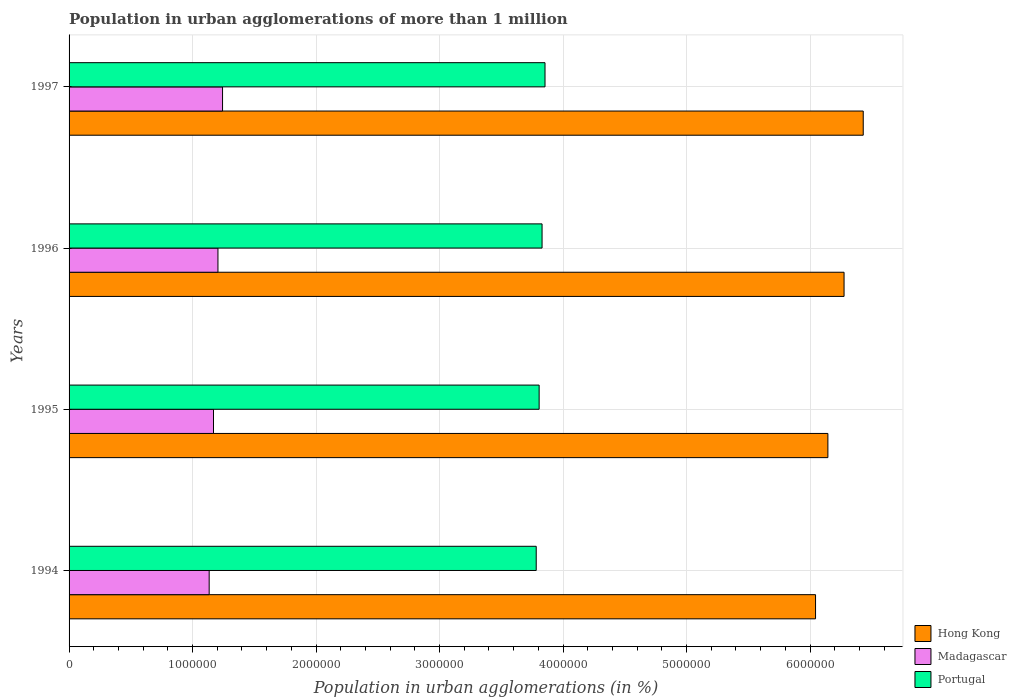Are the number of bars per tick equal to the number of legend labels?
Offer a very short reply. Yes. How many bars are there on the 1st tick from the top?
Give a very brief answer. 3. What is the population in urban agglomerations in Madagascar in 1994?
Your answer should be very brief. 1.13e+06. Across all years, what is the maximum population in urban agglomerations in Madagascar?
Your answer should be very brief. 1.24e+06. Across all years, what is the minimum population in urban agglomerations in Madagascar?
Your response must be concise. 1.13e+06. In which year was the population in urban agglomerations in Hong Kong maximum?
Ensure brevity in your answer.  1997. What is the total population in urban agglomerations in Hong Kong in the graph?
Your response must be concise. 2.49e+07. What is the difference between the population in urban agglomerations in Portugal in 1996 and that in 1997?
Your answer should be very brief. -2.38e+04. What is the difference between the population in urban agglomerations in Portugal in 1994 and the population in urban agglomerations in Madagascar in 1996?
Provide a short and direct response. 2.58e+06. What is the average population in urban agglomerations in Portugal per year?
Keep it short and to the point. 3.82e+06. In the year 1997, what is the difference between the population in urban agglomerations in Hong Kong and population in urban agglomerations in Madagascar?
Your response must be concise. 5.19e+06. In how many years, is the population in urban agglomerations in Hong Kong greater than 3200000 %?
Offer a terse response. 4. What is the ratio of the population in urban agglomerations in Madagascar in 1994 to that in 1995?
Make the answer very short. 0.97. Is the population in urban agglomerations in Portugal in 1995 less than that in 1996?
Give a very brief answer. Yes. Is the difference between the population in urban agglomerations in Hong Kong in 1994 and 1996 greater than the difference between the population in urban agglomerations in Madagascar in 1994 and 1996?
Your answer should be very brief. No. What is the difference between the highest and the second highest population in urban agglomerations in Hong Kong?
Give a very brief answer. 1.55e+05. What is the difference between the highest and the lowest population in urban agglomerations in Hong Kong?
Ensure brevity in your answer.  3.86e+05. What does the 2nd bar from the top in 1995 represents?
Provide a succinct answer. Madagascar. Is it the case that in every year, the sum of the population in urban agglomerations in Madagascar and population in urban agglomerations in Portugal is greater than the population in urban agglomerations in Hong Kong?
Ensure brevity in your answer.  No. How many years are there in the graph?
Make the answer very short. 4. What is the difference between two consecutive major ticks on the X-axis?
Offer a very short reply. 1.00e+06. Are the values on the major ticks of X-axis written in scientific E-notation?
Give a very brief answer. No. What is the title of the graph?
Your answer should be compact. Population in urban agglomerations of more than 1 million. Does "Hong Kong" appear as one of the legend labels in the graph?
Make the answer very short. Yes. What is the label or title of the X-axis?
Provide a succinct answer. Population in urban agglomerations (in %). What is the label or title of the Y-axis?
Offer a very short reply. Years. What is the Population in urban agglomerations (in %) of Hong Kong in 1994?
Your response must be concise. 6.04e+06. What is the Population in urban agglomerations (in %) in Madagascar in 1994?
Keep it short and to the point. 1.13e+06. What is the Population in urban agglomerations (in %) in Portugal in 1994?
Offer a terse response. 3.78e+06. What is the Population in urban agglomerations (in %) of Hong Kong in 1995?
Make the answer very short. 6.14e+06. What is the Population in urban agglomerations (in %) of Madagascar in 1995?
Your response must be concise. 1.17e+06. What is the Population in urban agglomerations (in %) of Portugal in 1995?
Your answer should be compact. 3.81e+06. What is the Population in urban agglomerations (in %) in Hong Kong in 1996?
Ensure brevity in your answer.  6.28e+06. What is the Population in urban agglomerations (in %) in Madagascar in 1996?
Your response must be concise. 1.21e+06. What is the Population in urban agglomerations (in %) of Portugal in 1996?
Give a very brief answer. 3.83e+06. What is the Population in urban agglomerations (in %) of Hong Kong in 1997?
Ensure brevity in your answer.  6.43e+06. What is the Population in urban agglomerations (in %) of Madagascar in 1997?
Make the answer very short. 1.24e+06. What is the Population in urban agglomerations (in %) in Portugal in 1997?
Give a very brief answer. 3.85e+06. Across all years, what is the maximum Population in urban agglomerations (in %) of Hong Kong?
Offer a terse response. 6.43e+06. Across all years, what is the maximum Population in urban agglomerations (in %) of Madagascar?
Offer a very short reply. 1.24e+06. Across all years, what is the maximum Population in urban agglomerations (in %) of Portugal?
Your answer should be compact. 3.85e+06. Across all years, what is the minimum Population in urban agglomerations (in %) in Hong Kong?
Offer a very short reply. 6.04e+06. Across all years, what is the minimum Population in urban agglomerations (in %) in Madagascar?
Provide a succinct answer. 1.13e+06. Across all years, what is the minimum Population in urban agglomerations (in %) in Portugal?
Give a very brief answer. 3.78e+06. What is the total Population in urban agglomerations (in %) of Hong Kong in the graph?
Ensure brevity in your answer.  2.49e+07. What is the total Population in urban agglomerations (in %) of Madagascar in the graph?
Provide a succinct answer. 4.75e+06. What is the total Population in urban agglomerations (in %) in Portugal in the graph?
Offer a very short reply. 1.53e+07. What is the difference between the Population in urban agglomerations (in %) in Hong Kong in 1994 and that in 1995?
Offer a terse response. -1.00e+05. What is the difference between the Population in urban agglomerations (in %) in Madagascar in 1994 and that in 1995?
Provide a short and direct response. -3.50e+04. What is the difference between the Population in urban agglomerations (in %) in Portugal in 1994 and that in 1995?
Give a very brief answer. -2.36e+04. What is the difference between the Population in urban agglomerations (in %) in Hong Kong in 1994 and that in 1996?
Your answer should be compact. -2.31e+05. What is the difference between the Population in urban agglomerations (in %) in Madagascar in 1994 and that in 1996?
Your answer should be compact. -7.12e+04. What is the difference between the Population in urban agglomerations (in %) of Portugal in 1994 and that in 1996?
Make the answer very short. -4.73e+04. What is the difference between the Population in urban agglomerations (in %) of Hong Kong in 1994 and that in 1997?
Keep it short and to the point. -3.86e+05. What is the difference between the Population in urban agglomerations (in %) of Madagascar in 1994 and that in 1997?
Your answer should be compact. -1.08e+05. What is the difference between the Population in urban agglomerations (in %) of Portugal in 1994 and that in 1997?
Make the answer very short. -7.11e+04. What is the difference between the Population in urban agglomerations (in %) in Hong Kong in 1995 and that in 1996?
Make the answer very short. -1.31e+05. What is the difference between the Population in urban agglomerations (in %) in Madagascar in 1995 and that in 1996?
Give a very brief answer. -3.61e+04. What is the difference between the Population in urban agglomerations (in %) of Portugal in 1995 and that in 1996?
Offer a very short reply. -2.37e+04. What is the difference between the Population in urban agglomerations (in %) of Hong Kong in 1995 and that in 1997?
Ensure brevity in your answer.  -2.86e+05. What is the difference between the Population in urban agglomerations (in %) of Madagascar in 1995 and that in 1997?
Give a very brief answer. -7.33e+04. What is the difference between the Population in urban agglomerations (in %) in Portugal in 1995 and that in 1997?
Your answer should be compact. -4.76e+04. What is the difference between the Population in urban agglomerations (in %) of Hong Kong in 1996 and that in 1997?
Ensure brevity in your answer.  -1.55e+05. What is the difference between the Population in urban agglomerations (in %) in Madagascar in 1996 and that in 1997?
Offer a terse response. -3.72e+04. What is the difference between the Population in urban agglomerations (in %) in Portugal in 1996 and that in 1997?
Ensure brevity in your answer.  -2.38e+04. What is the difference between the Population in urban agglomerations (in %) in Hong Kong in 1994 and the Population in urban agglomerations (in %) in Madagascar in 1995?
Your response must be concise. 4.88e+06. What is the difference between the Population in urban agglomerations (in %) of Hong Kong in 1994 and the Population in urban agglomerations (in %) of Portugal in 1995?
Ensure brevity in your answer.  2.24e+06. What is the difference between the Population in urban agglomerations (in %) of Madagascar in 1994 and the Population in urban agglomerations (in %) of Portugal in 1995?
Offer a very short reply. -2.67e+06. What is the difference between the Population in urban agglomerations (in %) in Hong Kong in 1994 and the Population in urban agglomerations (in %) in Madagascar in 1996?
Make the answer very short. 4.84e+06. What is the difference between the Population in urban agglomerations (in %) in Hong Kong in 1994 and the Population in urban agglomerations (in %) in Portugal in 1996?
Provide a succinct answer. 2.21e+06. What is the difference between the Population in urban agglomerations (in %) of Madagascar in 1994 and the Population in urban agglomerations (in %) of Portugal in 1996?
Provide a succinct answer. -2.70e+06. What is the difference between the Population in urban agglomerations (in %) in Hong Kong in 1994 and the Population in urban agglomerations (in %) in Madagascar in 1997?
Make the answer very short. 4.80e+06. What is the difference between the Population in urban agglomerations (in %) in Hong Kong in 1994 and the Population in urban agglomerations (in %) in Portugal in 1997?
Offer a terse response. 2.19e+06. What is the difference between the Population in urban agglomerations (in %) in Madagascar in 1994 and the Population in urban agglomerations (in %) in Portugal in 1997?
Make the answer very short. -2.72e+06. What is the difference between the Population in urban agglomerations (in %) in Hong Kong in 1995 and the Population in urban agglomerations (in %) in Madagascar in 1996?
Provide a short and direct response. 4.94e+06. What is the difference between the Population in urban agglomerations (in %) in Hong Kong in 1995 and the Population in urban agglomerations (in %) in Portugal in 1996?
Offer a terse response. 2.31e+06. What is the difference between the Population in urban agglomerations (in %) in Madagascar in 1995 and the Population in urban agglomerations (in %) in Portugal in 1996?
Ensure brevity in your answer.  -2.66e+06. What is the difference between the Population in urban agglomerations (in %) in Hong Kong in 1995 and the Population in urban agglomerations (in %) in Madagascar in 1997?
Keep it short and to the point. 4.90e+06. What is the difference between the Population in urban agglomerations (in %) in Hong Kong in 1995 and the Population in urban agglomerations (in %) in Portugal in 1997?
Your answer should be compact. 2.29e+06. What is the difference between the Population in urban agglomerations (in %) of Madagascar in 1995 and the Population in urban agglomerations (in %) of Portugal in 1997?
Ensure brevity in your answer.  -2.68e+06. What is the difference between the Population in urban agglomerations (in %) in Hong Kong in 1996 and the Population in urban agglomerations (in %) in Madagascar in 1997?
Ensure brevity in your answer.  5.03e+06. What is the difference between the Population in urban agglomerations (in %) of Hong Kong in 1996 and the Population in urban agglomerations (in %) of Portugal in 1997?
Offer a very short reply. 2.42e+06. What is the difference between the Population in urban agglomerations (in %) of Madagascar in 1996 and the Population in urban agglomerations (in %) of Portugal in 1997?
Keep it short and to the point. -2.65e+06. What is the average Population in urban agglomerations (in %) of Hong Kong per year?
Your response must be concise. 6.22e+06. What is the average Population in urban agglomerations (in %) in Madagascar per year?
Your response must be concise. 1.19e+06. What is the average Population in urban agglomerations (in %) of Portugal per year?
Make the answer very short. 3.82e+06. In the year 1994, what is the difference between the Population in urban agglomerations (in %) in Hong Kong and Population in urban agglomerations (in %) in Madagascar?
Provide a short and direct response. 4.91e+06. In the year 1994, what is the difference between the Population in urban agglomerations (in %) of Hong Kong and Population in urban agglomerations (in %) of Portugal?
Your response must be concise. 2.26e+06. In the year 1994, what is the difference between the Population in urban agglomerations (in %) in Madagascar and Population in urban agglomerations (in %) in Portugal?
Keep it short and to the point. -2.65e+06. In the year 1995, what is the difference between the Population in urban agglomerations (in %) of Hong Kong and Population in urban agglomerations (in %) of Madagascar?
Provide a short and direct response. 4.98e+06. In the year 1995, what is the difference between the Population in urban agglomerations (in %) of Hong Kong and Population in urban agglomerations (in %) of Portugal?
Provide a succinct answer. 2.34e+06. In the year 1995, what is the difference between the Population in urban agglomerations (in %) of Madagascar and Population in urban agglomerations (in %) of Portugal?
Your answer should be very brief. -2.64e+06. In the year 1996, what is the difference between the Population in urban agglomerations (in %) in Hong Kong and Population in urban agglomerations (in %) in Madagascar?
Offer a terse response. 5.07e+06. In the year 1996, what is the difference between the Population in urban agglomerations (in %) of Hong Kong and Population in urban agglomerations (in %) of Portugal?
Your response must be concise. 2.45e+06. In the year 1996, what is the difference between the Population in urban agglomerations (in %) in Madagascar and Population in urban agglomerations (in %) in Portugal?
Ensure brevity in your answer.  -2.62e+06. In the year 1997, what is the difference between the Population in urban agglomerations (in %) of Hong Kong and Population in urban agglomerations (in %) of Madagascar?
Ensure brevity in your answer.  5.19e+06. In the year 1997, what is the difference between the Population in urban agglomerations (in %) in Hong Kong and Population in urban agglomerations (in %) in Portugal?
Your answer should be compact. 2.58e+06. In the year 1997, what is the difference between the Population in urban agglomerations (in %) of Madagascar and Population in urban agglomerations (in %) of Portugal?
Your answer should be very brief. -2.61e+06. What is the ratio of the Population in urban agglomerations (in %) of Hong Kong in 1994 to that in 1995?
Provide a short and direct response. 0.98. What is the ratio of the Population in urban agglomerations (in %) of Madagascar in 1994 to that in 1995?
Provide a short and direct response. 0.97. What is the ratio of the Population in urban agglomerations (in %) of Portugal in 1994 to that in 1995?
Provide a short and direct response. 0.99. What is the ratio of the Population in urban agglomerations (in %) of Hong Kong in 1994 to that in 1996?
Your answer should be compact. 0.96. What is the ratio of the Population in urban agglomerations (in %) in Madagascar in 1994 to that in 1996?
Give a very brief answer. 0.94. What is the ratio of the Population in urban agglomerations (in %) of Portugal in 1994 to that in 1996?
Your answer should be very brief. 0.99. What is the ratio of the Population in urban agglomerations (in %) of Hong Kong in 1994 to that in 1997?
Give a very brief answer. 0.94. What is the ratio of the Population in urban agglomerations (in %) in Madagascar in 1994 to that in 1997?
Offer a very short reply. 0.91. What is the ratio of the Population in urban agglomerations (in %) in Portugal in 1994 to that in 1997?
Give a very brief answer. 0.98. What is the ratio of the Population in urban agglomerations (in %) in Hong Kong in 1995 to that in 1996?
Provide a succinct answer. 0.98. What is the ratio of the Population in urban agglomerations (in %) in Madagascar in 1995 to that in 1996?
Your response must be concise. 0.97. What is the ratio of the Population in urban agglomerations (in %) of Portugal in 1995 to that in 1996?
Make the answer very short. 0.99. What is the ratio of the Population in urban agglomerations (in %) in Hong Kong in 1995 to that in 1997?
Your answer should be compact. 0.96. What is the ratio of the Population in urban agglomerations (in %) of Madagascar in 1995 to that in 1997?
Provide a short and direct response. 0.94. What is the ratio of the Population in urban agglomerations (in %) in Hong Kong in 1996 to that in 1997?
Provide a short and direct response. 0.98. What is the ratio of the Population in urban agglomerations (in %) in Madagascar in 1996 to that in 1997?
Your answer should be compact. 0.97. What is the difference between the highest and the second highest Population in urban agglomerations (in %) of Hong Kong?
Your answer should be very brief. 1.55e+05. What is the difference between the highest and the second highest Population in urban agglomerations (in %) in Madagascar?
Keep it short and to the point. 3.72e+04. What is the difference between the highest and the second highest Population in urban agglomerations (in %) of Portugal?
Offer a very short reply. 2.38e+04. What is the difference between the highest and the lowest Population in urban agglomerations (in %) in Hong Kong?
Offer a terse response. 3.86e+05. What is the difference between the highest and the lowest Population in urban agglomerations (in %) in Madagascar?
Make the answer very short. 1.08e+05. What is the difference between the highest and the lowest Population in urban agglomerations (in %) in Portugal?
Offer a very short reply. 7.11e+04. 